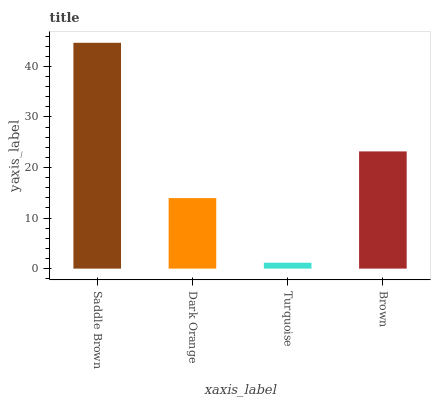Is Turquoise the minimum?
Answer yes or no. Yes. Is Saddle Brown the maximum?
Answer yes or no. Yes. Is Dark Orange the minimum?
Answer yes or no. No. Is Dark Orange the maximum?
Answer yes or no. No. Is Saddle Brown greater than Dark Orange?
Answer yes or no. Yes. Is Dark Orange less than Saddle Brown?
Answer yes or no. Yes. Is Dark Orange greater than Saddle Brown?
Answer yes or no. No. Is Saddle Brown less than Dark Orange?
Answer yes or no. No. Is Brown the high median?
Answer yes or no. Yes. Is Dark Orange the low median?
Answer yes or no. Yes. Is Dark Orange the high median?
Answer yes or no. No. Is Saddle Brown the low median?
Answer yes or no. No. 